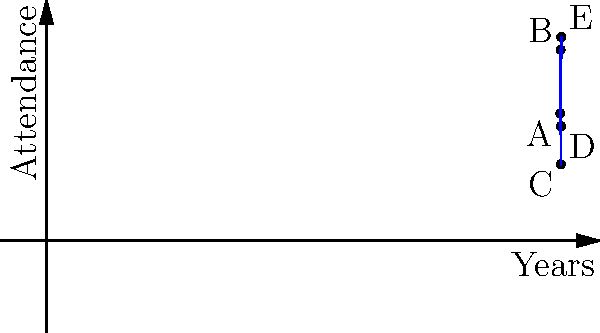The graph shows the attendance at an annual communications conference from 2018 to 2022. Which year saw the most significant percentage increase in attendance compared to the previous year, and what was this percentage increase? To solve this problem, we need to calculate the percentage increase for each year and compare them:

1. From 2018 to 2019:
   Increase = 750 - 500 = 250
   Percentage increase = (250 / 500) * 100 = 50%

2. From 2019 to 2020:
   Decrease = 750 - 300 = 450
   Percentage decrease = (450 / 750) * 100 = 60%
   (This is a decrease, not an increase)

3. From 2020 to 2021:
   Increase = 450 - 300 = 150
   Percentage increase = (150 / 300) * 100 = 50%

4. From 2021 to 2022:
   Increase = 800 - 450 = 350
   Percentage increase = (350 / 450) * 100 = 77.78%

The largest percentage increase was from 2021 to 2022, with an increase of approximately 77.78%.
Answer: 2022, 77.78% 